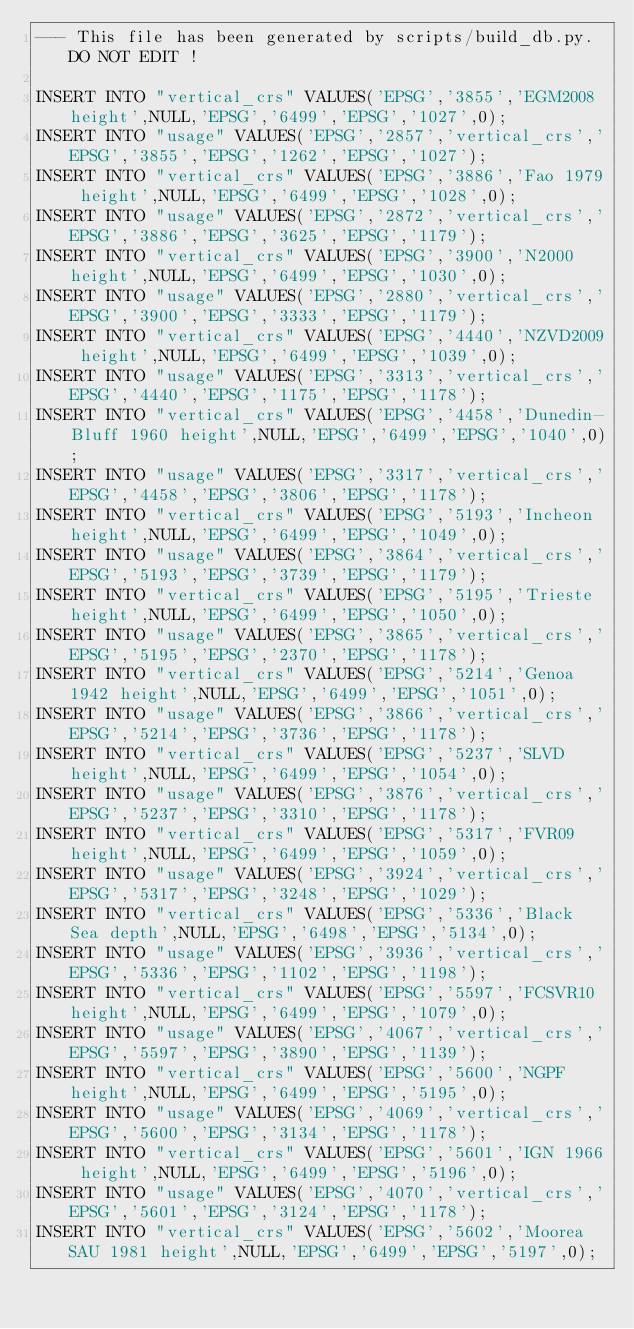Convert code to text. <code><loc_0><loc_0><loc_500><loc_500><_SQL_>--- This file has been generated by scripts/build_db.py. DO NOT EDIT !

INSERT INTO "vertical_crs" VALUES('EPSG','3855','EGM2008 height',NULL,'EPSG','6499','EPSG','1027',0);
INSERT INTO "usage" VALUES('EPSG','2857','vertical_crs','EPSG','3855','EPSG','1262','EPSG','1027');
INSERT INTO "vertical_crs" VALUES('EPSG','3886','Fao 1979 height',NULL,'EPSG','6499','EPSG','1028',0);
INSERT INTO "usage" VALUES('EPSG','2872','vertical_crs','EPSG','3886','EPSG','3625','EPSG','1179');
INSERT INTO "vertical_crs" VALUES('EPSG','3900','N2000 height',NULL,'EPSG','6499','EPSG','1030',0);
INSERT INTO "usage" VALUES('EPSG','2880','vertical_crs','EPSG','3900','EPSG','3333','EPSG','1179');
INSERT INTO "vertical_crs" VALUES('EPSG','4440','NZVD2009 height',NULL,'EPSG','6499','EPSG','1039',0);
INSERT INTO "usage" VALUES('EPSG','3313','vertical_crs','EPSG','4440','EPSG','1175','EPSG','1178');
INSERT INTO "vertical_crs" VALUES('EPSG','4458','Dunedin-Bluff 1960 height',NULL,'EPSG','6499','EPSG','1040',0);
INSERT INTO "usage" VALUES('EPSG','3317','vertical_crs','EPSG','4458','EPSG','3806','EPSG','1178');
INSERT INTO "vertical_crs" VALUES('EPSG','5193','Incheon height',NULL,'EPSG','6499','EPSG','1049',0);
INSERT INTO "usage" VALUES('EPSG','3864','vertical_crs','EPSG','5193','EPSG','3739','EPSG','1179');
INSERT INTO "vertical_crs" VALUES('EPSG','5195','Trieste height',NULL,'EPSG','6499','EPSG','1050',0);
INSERT INTO "usage" VALUES('EPSG','3865','vertical_crs','EPSG','5195','EPSG','2370','EPSG','1178');
INSERT INTO "vertical_crs" VALUES('EPSG','5214','Genoa 1942 height',NULL,'EPSG','6499','EPSG','1051',0);
INSERT INTO "usage" VALUES('EPSG','3866','vertical_crs','EPSG','5214','EPSG','3736','EPSG','1178');
INSERT INTO "vertical_crs" VALUES('EPSG','5237','SLVD height',NULL,'EPSG','6499','EPSG','1054',0);
INSERT INTO "usage" VALUES('EPSG','3876','vertical_crs','EPSG','5237','EPSG','3310','EPSG','1178');
INSERT INTO "vertical_crs" VALUES('EPSG','5317','FVR09 height',NULL,'EPSG','6499','EPSG','1059',0);
INSERT INTO "usage" VALUES('EPSG','3924','vertical_crs','EPSG','5317','EPSG','3248','EPSG','1029');
INSERT INTO "vertical_crs" VALUES('EPSG','5336','Black Sea depth',NULL,'EPSG','6498','EPSG','5134',0);
INSERT INTO "usage" VALUES('EPSG','3936','vertical_crs','EPSG','5336','EPSG','1102','EPSG','1198');
INSERT INTO "vertical_crs" VALUES('EPSG','5597','FCSVR10 height',NULL,'EPSG','6499','EPSG','1079',0);
INSERT INTO "usage" VALUES('EPSG','4067','vertical_crs','EPSG','5597','EPSG','3890','EPSG','1139');
INSERT INTO "vertical_crs" VALUES('EPSG','5600','NGPF height',NULL,'EPSG','6499','EPSG','5195',0);
INSERT INTO "usage" VALUES('EPSG','4069','vertical_crs','EPSG','5600','EPSG','3134','EPSG','1178');
INSERT INTO "vertical_crs" VALUES('EPSG','5601','IGN 1966 height',NULL,'EPSG','6499','EPSG','5196',0);
INSERT INTO "usage" VALUES('EPSG','4070','vertical_crs','EPSG','5601','EPSG','3124','EPSG','1178');
INSERT INTO "vertical_crs" VALUES('EPSG','5602','Moorea SAU 1981 height',NULL,'EPSG','6499','EPSG','5197',0);</code> 